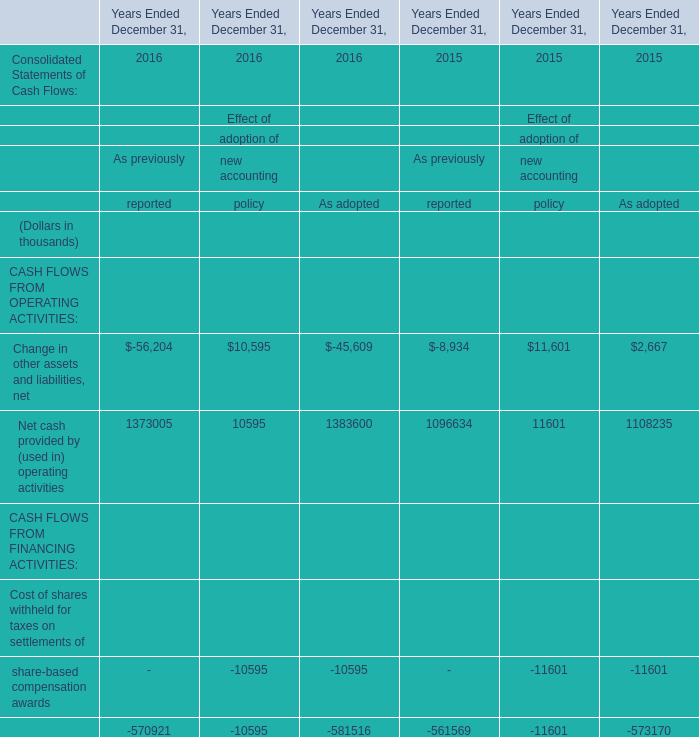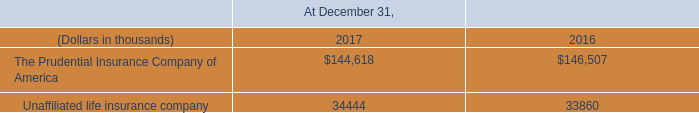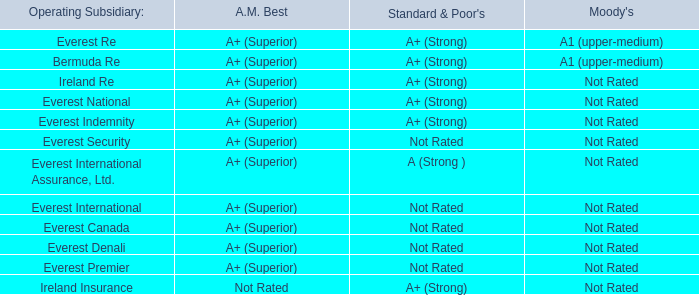What is the average growth rate of Net cash provided between 2015 and 2016 for As previously? 
Computations: (((1373005 - 1096634) / 1096634) / 1)
Answer: 0.25202. 